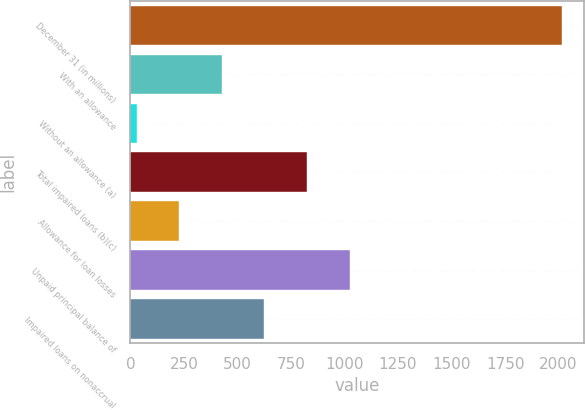Convert chart to OTSL. <chart><loc_0><loc_0><loc_500><loc_500><bar_chart><fcel>December 31 (in millions)<fcel>With an allowance<fcel>Without an allowance (a)<fcel>Total impaired loans (b)(c)<fcel>Allowance for loan losses<fcel>Unpaid principal balance of<fcel>Impaired loans on nonaccrual<nl><fcel>2018<fcel>426.8<fcel>29<fcel>824.6<fcel>227.9<fcel>1023.5<fcel>625.7<nl></chart> 